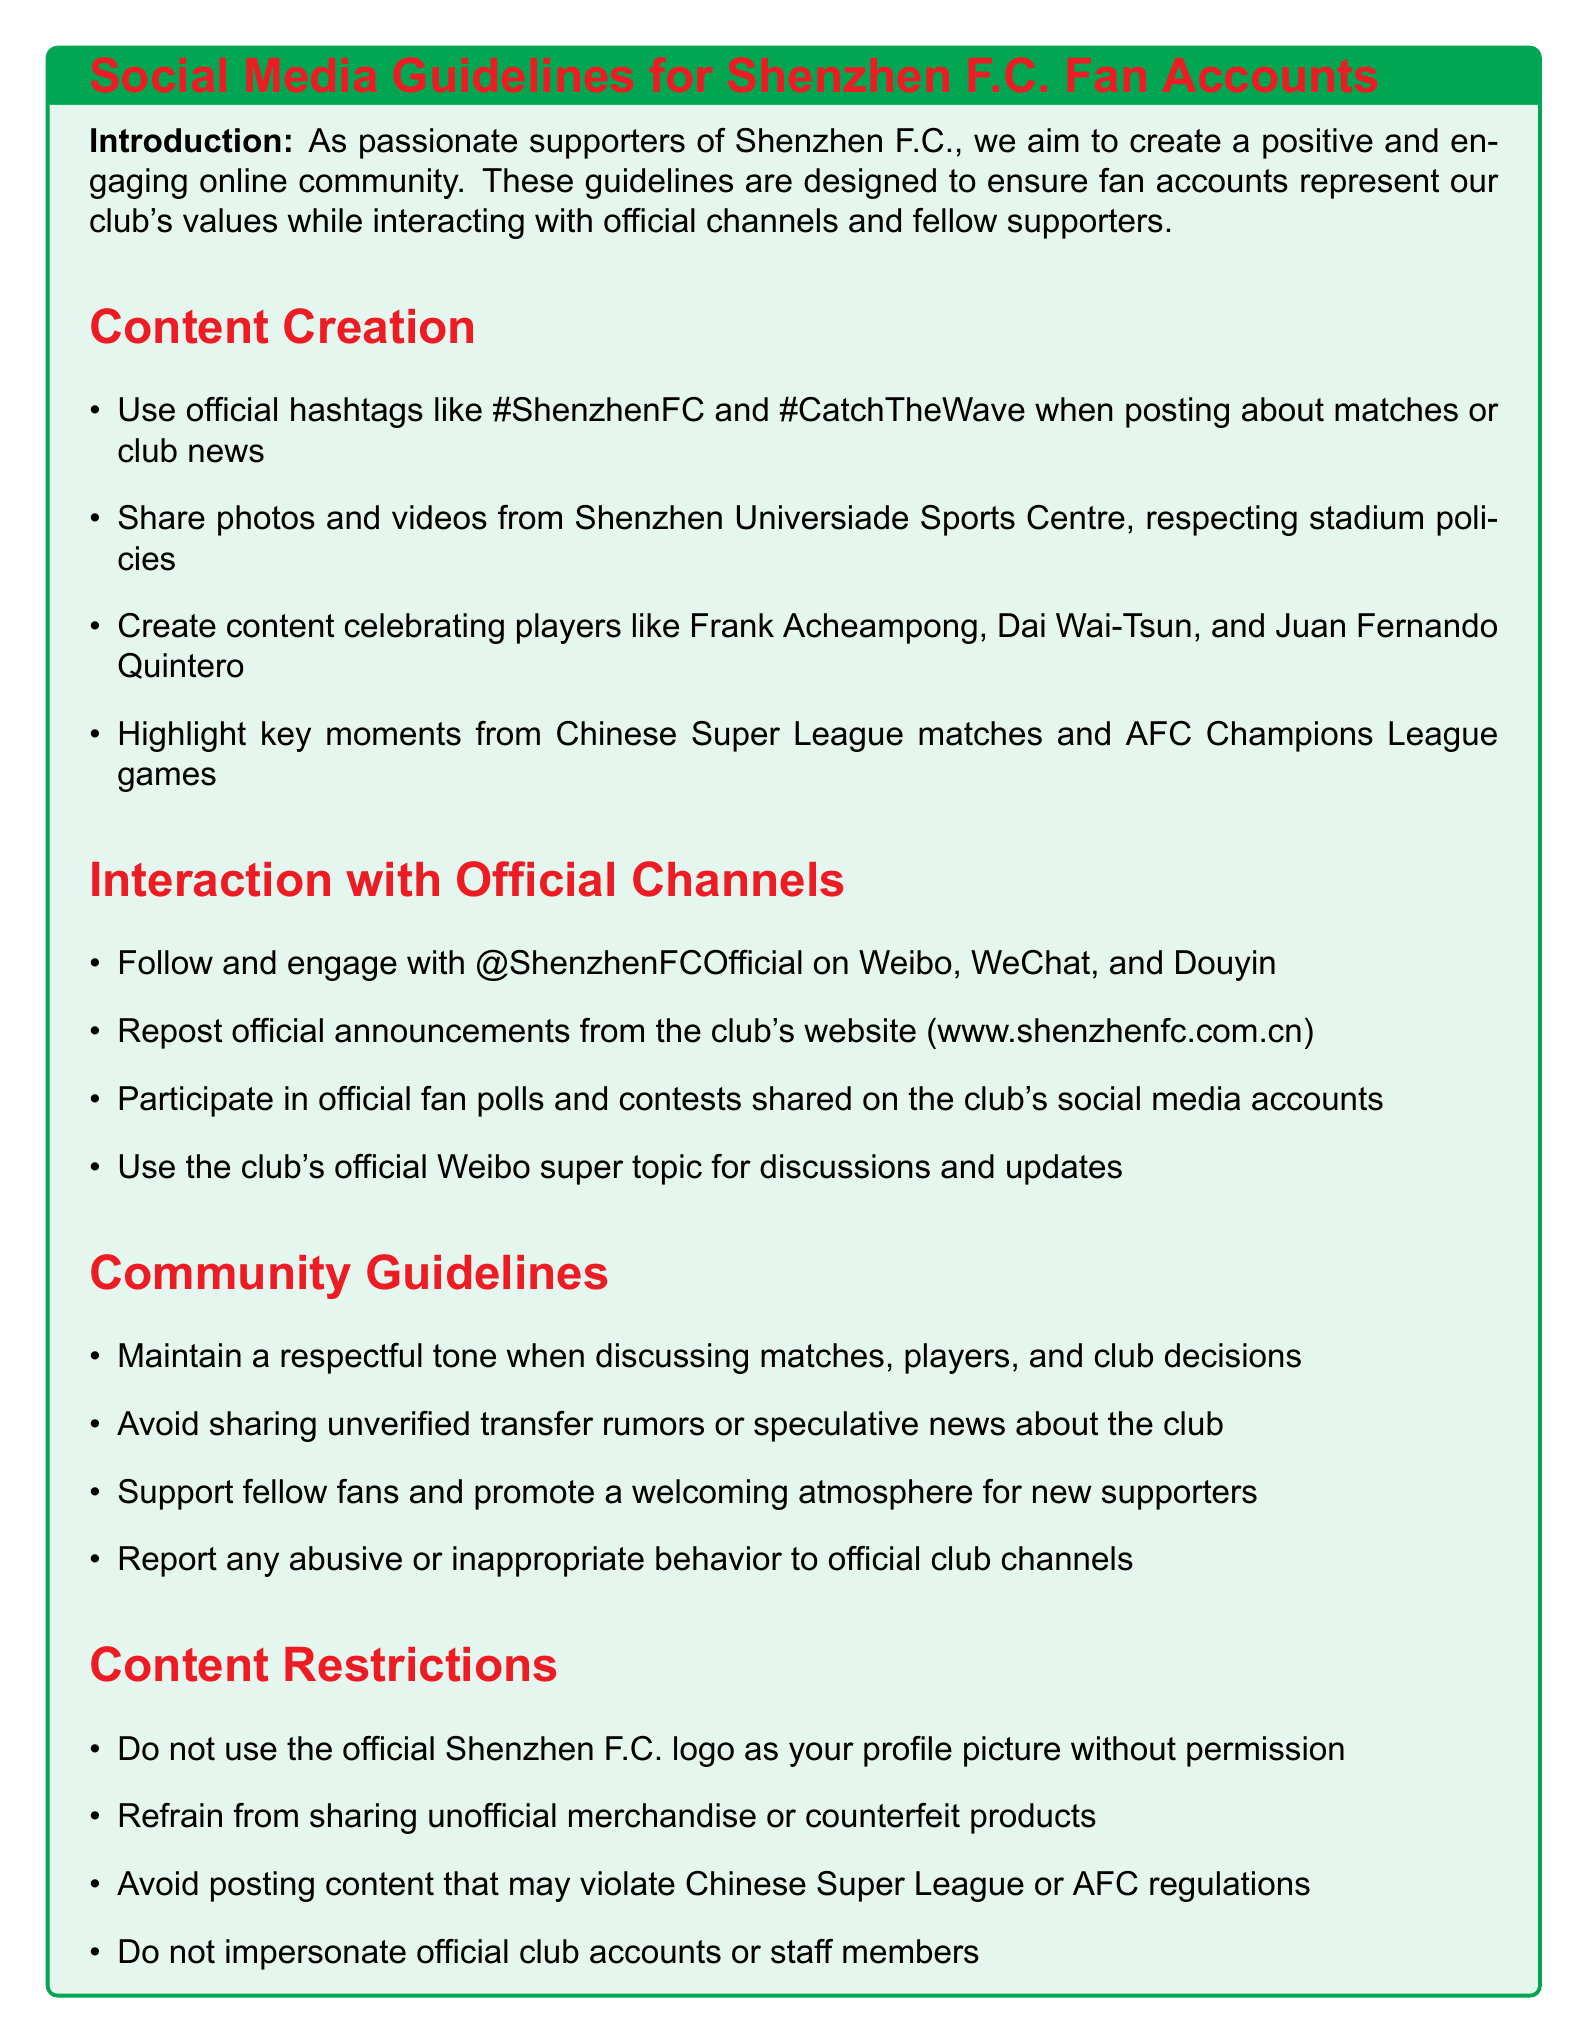what are the official hashtags to use? The document lists the official hashtags that fans should use when posting about matches or club news.
Answer: #ShenzhenFC and #CatchTheWave who are the players mentioned in the content creation section? The guidelines specifically mention players that should be celebrated in fan-created content.
Answer: Frank Acheampong, Dai Wai-Tsun, Juan Fernando Quintero which social media platforms should fans engage with the official club account? The document indicates which platforms fans should use to follow and engage with Shenzhen F.C.'s official account.
Answer: Weibo, WeChat, Douyin what is prohibited regarding the official Shenzhen F.C. logo? The guidelines outline specific restrictions related to the usage of the official club’s logo.
Answer: Do not use it as your profile picture without permission what is the tone fans should maintain when discussing matches or players? The document emphasizes the importance of tone when communicating online about the club and its affiliates.
Answer: Respectful how should fans interact with official announcements? The document instructs fans on how to properly engage with the club's communications.
Answer: Repost official announcements what should fans avoid sharing? The guidelines specify content that fans should not promote or disseminate to maintain club integrity.
Answer: Unverified transfer rumors what should fans use for discussions and updates? The document mentions a specific platform that fans should use for discussions related to the club.
Answer: Club's official Weibo super topic 